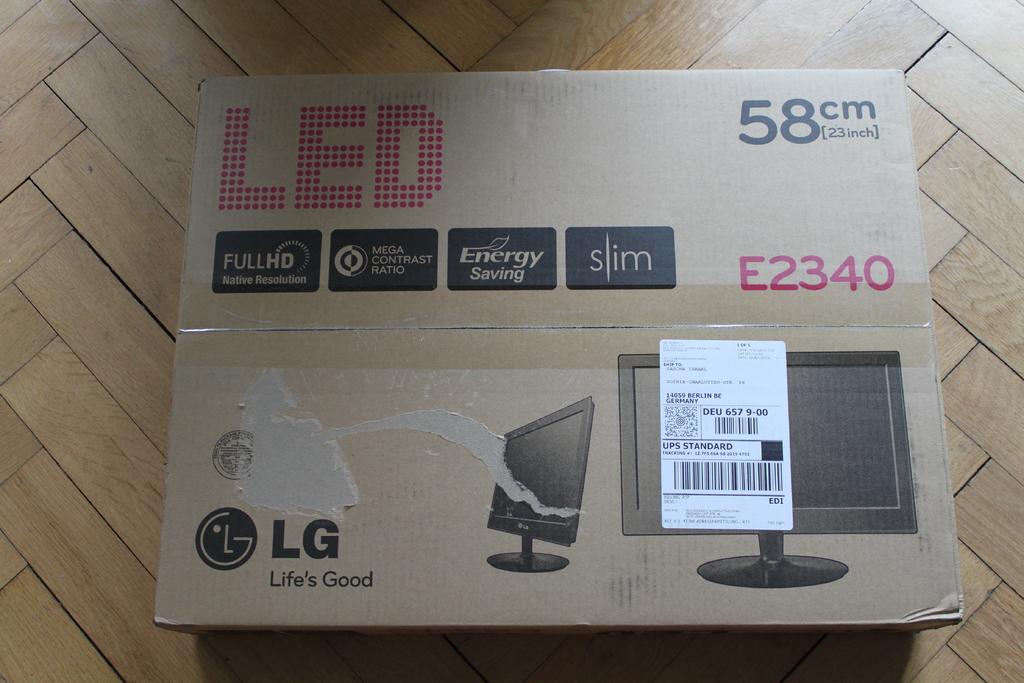What brand is this monitor?
Provide a short and direct response. Lg. What name is on the album on the left?
Give a very brief answer. Unanswerable. 